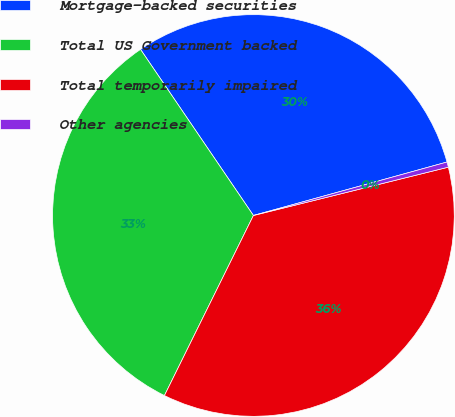Convert chart. <chart><loc_0><loc_0><loc_500><loc_500><pie_chart><fcel>Mortgage-backed securities<fcel>Total US Government backed<fcel>Total temporarily impaired<fcel>Other agencies<nl><fcel>30.21%<fcel>33.19%<fcel>36.17%<fcel>0.42%<nl></chart> 